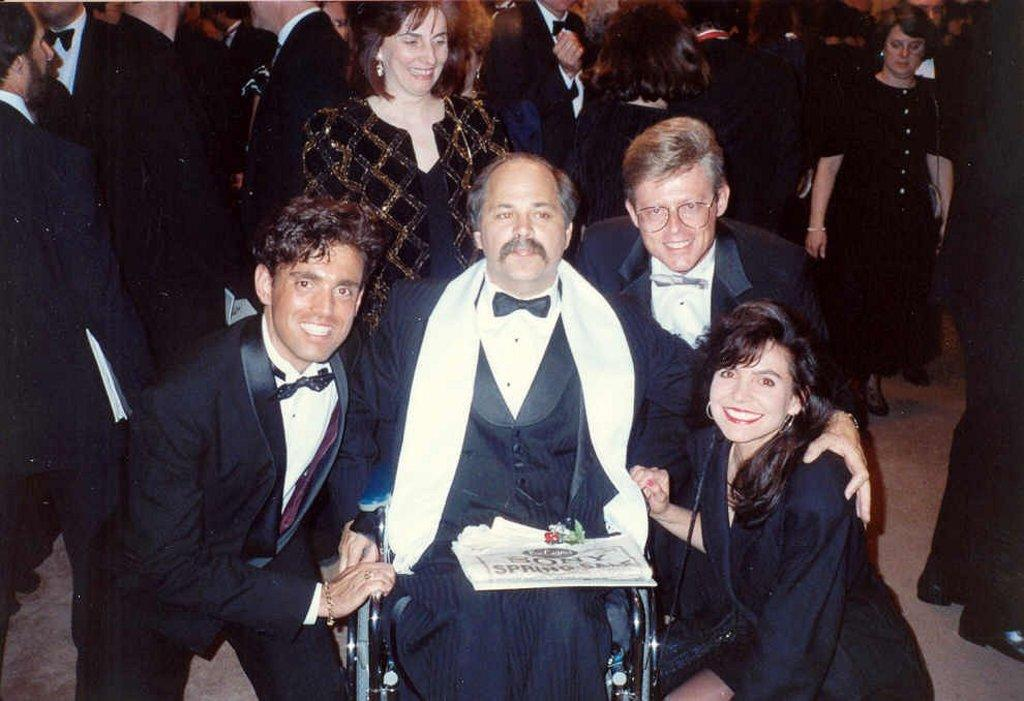How many people are in the image? There are 3 men and 2 women in the image, making a total of 5 people. What is the facial expression of the man in the middle? The man in the middle is not smiling. What is the facial expression of the other 4 people? The other 4 people (3 women and 1 man) are smiling. Can you describe the background of the image? There are people visible in the background of the image. What type of wren can be seen perched on the man's shoulder in the image? There is no wren present in the image; it only features people. What fact can be determined about the finger of the woman on the left? There is no information about the woman's fingers in the image, so it cannot be determined. 